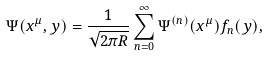Convert formula to latex. <formula><loc_0><loc_0><loc_500><loc_500>\Psi ( x ^ { \mu } , y ) = \frac { 1 } { \sqrt { 2 \pi R } } \sum _ { n = 0 } ^ { \infty } \Psi ^ { ( n ) } ( x ^ { \mu } ) f _ { n } ( y ) ,</formula> 